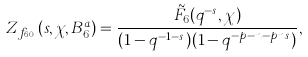Convert formula to latex. <formula><loc_0><loc_0><loc_500><loc_500>Z _ { f _ { 6 , 0 } } ( s , \chi , B _ { 6 } ^ { a } ) = \frac { \tilde { F } _ { 6 } ( q ^ { - s } , \chi ) } { ( 1 - q ^ { - 1 - s } ) ( 1 - q ^ { - p - n - p n s } ) } ,</formula> 